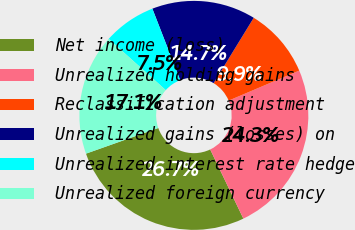Convert chart to OTSL. <chart><loc_0><loc_0><loc_500><loc_500><pie_chart><fcel>Net income (loss)<fcel>Unrealized holding gains<fcel>Reclassification adjustment<fcel>Unrealized gains (losses) on<fcel>Unrealized interest rate hedge<fcel>Unrealized foreign currency<nl><fcel>26.69%<fcel>24.28%<fcel>9.85%<fcel>14.66%<fcel>7.45%<fcel>17.07%<nl></chart> 